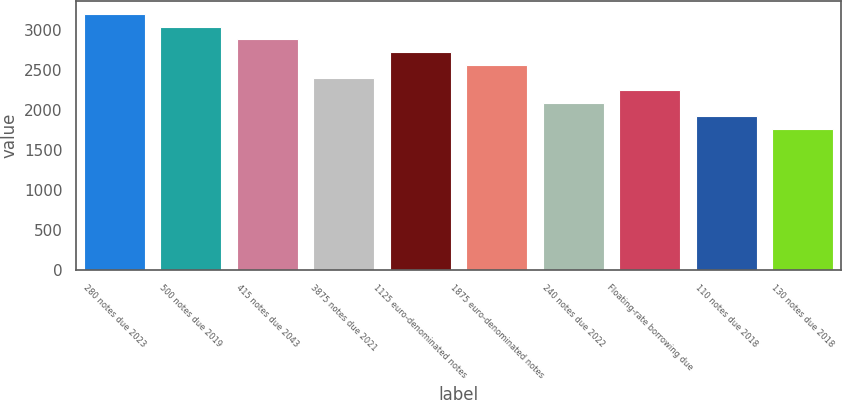Convert chart. <chart><loc_0><loc_0><loc_500><loc_500><bar_chart><fcel>280 notes due 2023<fcel>500 notes due 2019<fcel>415 notes due 2043<fcel>3875 notes due 2021<fcel>1125 euro-denominated notes<fcel>1875 euro-denominated notes<fcel>240 notes due 2022<fcel>Floating-rate borrowing due<fcel>110 notes due 2018<fcel>130 notes due 2018<nl><fcel>3200.6<fcel>3040.9<fcel>2881.2<fcel>2402.1<fcel>2721.5<fcel>2561.8<fcel>2082.7<fcel>2242.4<fcel>1923<fcel>1763.3<nl></chart> 